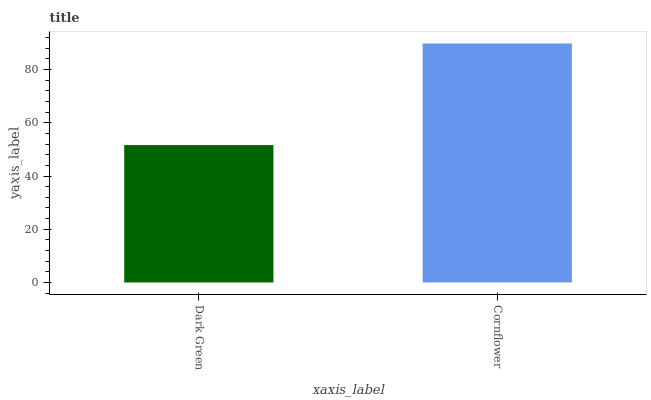Is Dark Green the minimum?
Answer yes or no. Yes. Is Cornflower the maximum?
Answer yes or no. Yes. Is Cornflower the minimum?
Answer yes or no. No. Is Cornflower greater than Dark Green?
Answer yes or no. Yes. Is Dark Green less than Cornflower?
Answer yes or no. Yes. Is Dark Green greater than Cornflower?
Answer yes or no. No. Is Cornflower less than Dark Green?
Answer yes or no. No. Is Cornflower the high median?
Answer yes or no. Yes. Is Dark Green the low median?
Answer yes or no. Yes. Is Dark Green the high median?
Answer yes or no. No. Is Cornflower the low median?
Answer yes or no. No. 